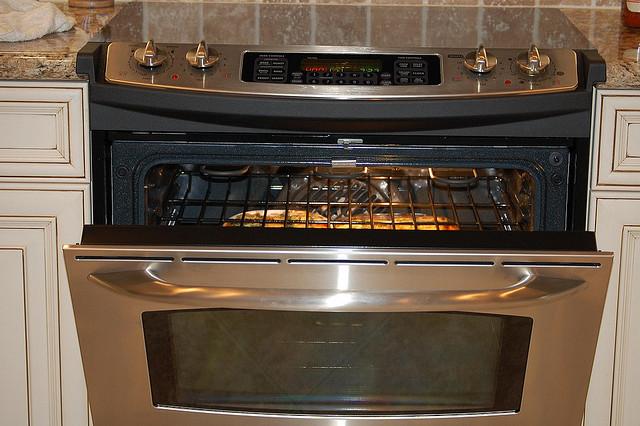What kind of pizza is this?
Short answer required. Cheese. What temp is the oven at?
Write a very short answer. 400. Is the oven white?
Write a very short answer. No. Is there any food in the oven?
Answer briefly. Yes. Is the oven door closed?
Keep it brief. No. 